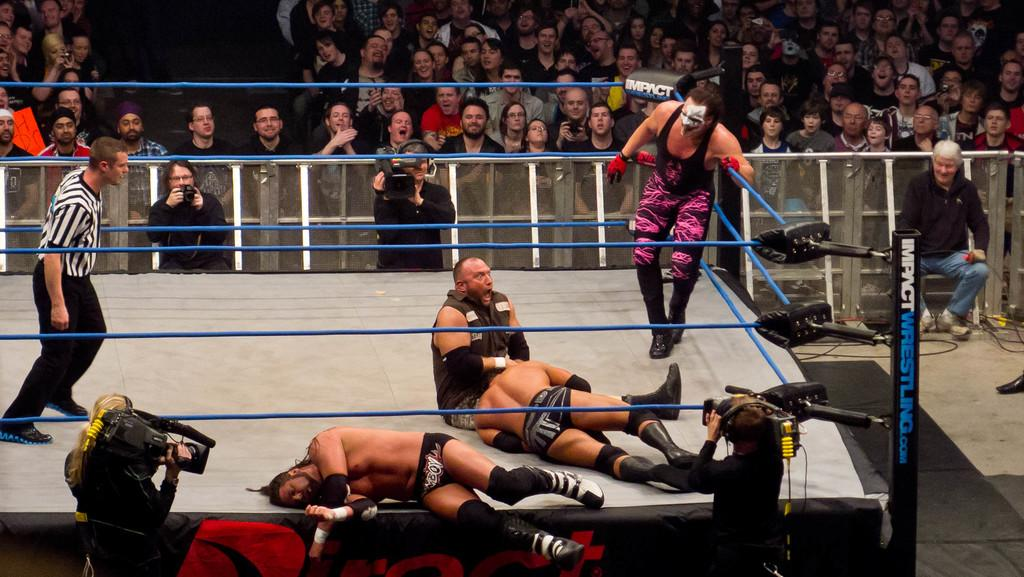<image>
Relay a brief, clear account of the picture shown. A wrestling ring displays the name Impact Wrestling on it in several places. 